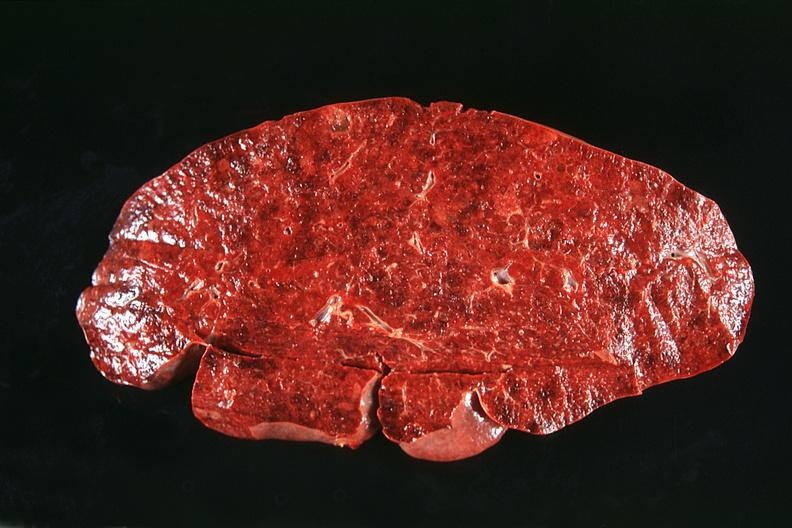does cervix duplication show spleen, normal?
Answer the question using a single word or phrase. No 